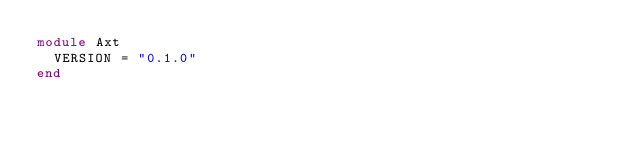<code> <loc_0><loc_0><loc_500><loc_500><_Ruby_>module Axt
  VERSION = "0.1.0"
end
</code> 